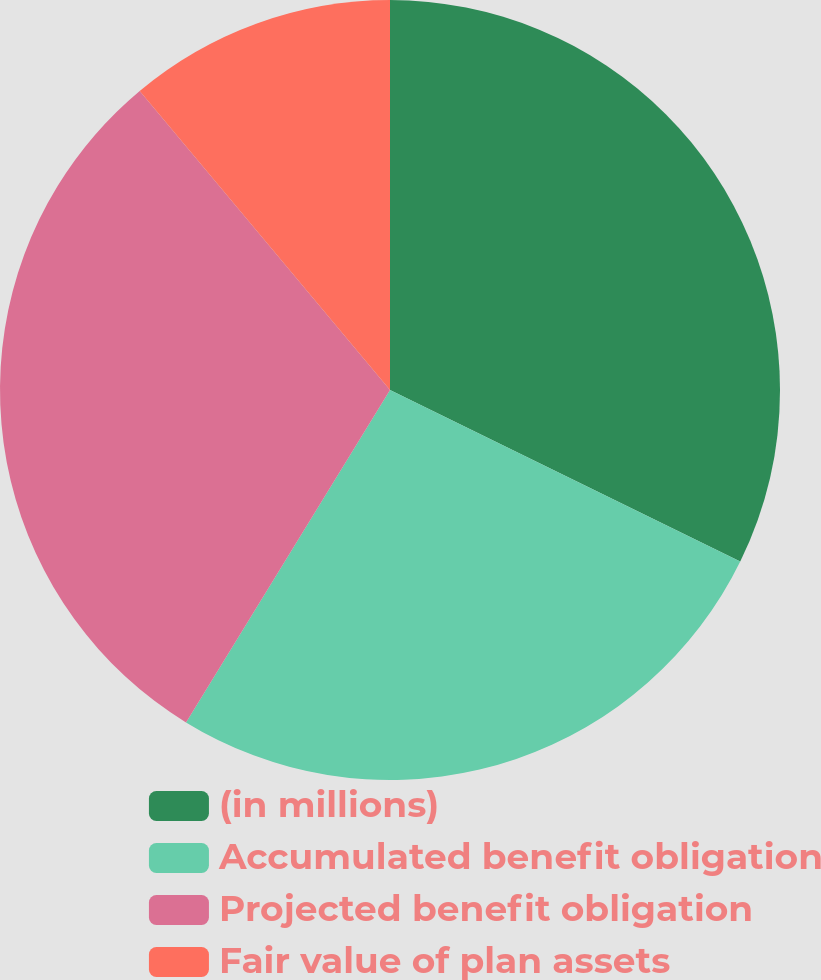Convert chart. <chart><loc_0><loc_0><loc_500><loc_500><pie_chart><fcel>(in millions)<fcel>Accumulated benefit obligation<fcel>Projected benefit obligation<fcel>Fair value of plan assets<nl><fcel>32.25%<fcel>26.51%<fcel>30.15%<fcel>11.09%<nl></chart> 